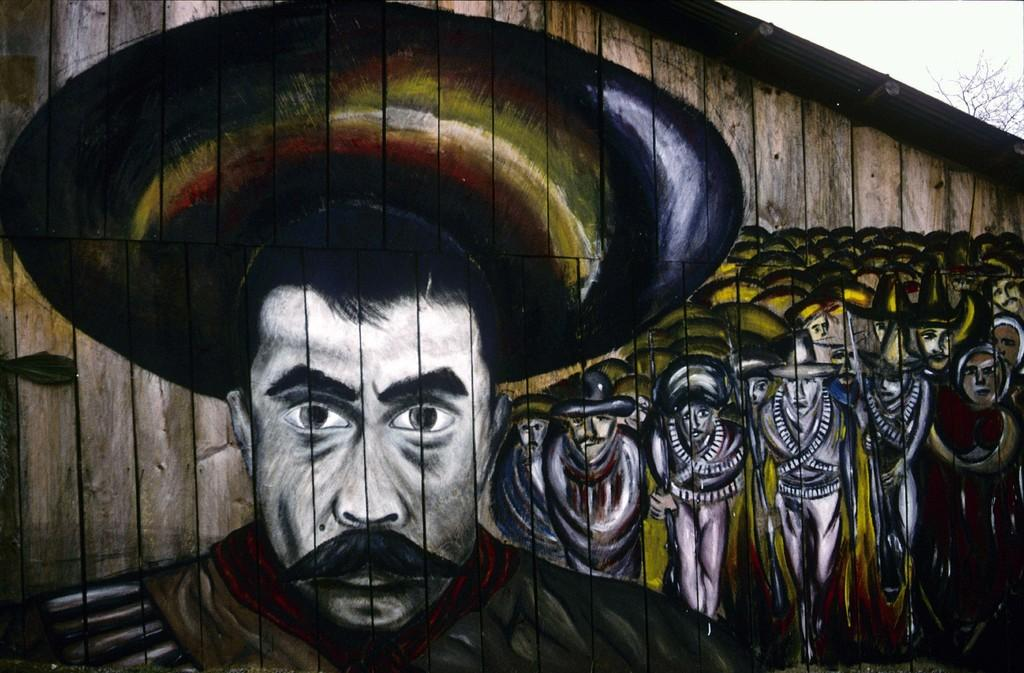What type of wall is featured in the image? There is a wooden wall in the image. What is depicted on the wooden wall? There is a painting of people on the wall. What can be seen at the top of the image? The sky is visible at the top of the image. How many bricks are used to construct the wall in the image? The wall in the image is made of wood, not bricks, so it is not possible to determine the number of bricks used. Can you describe the plane flying in the sky in the image? There is no plane visible in the sky in the image. 